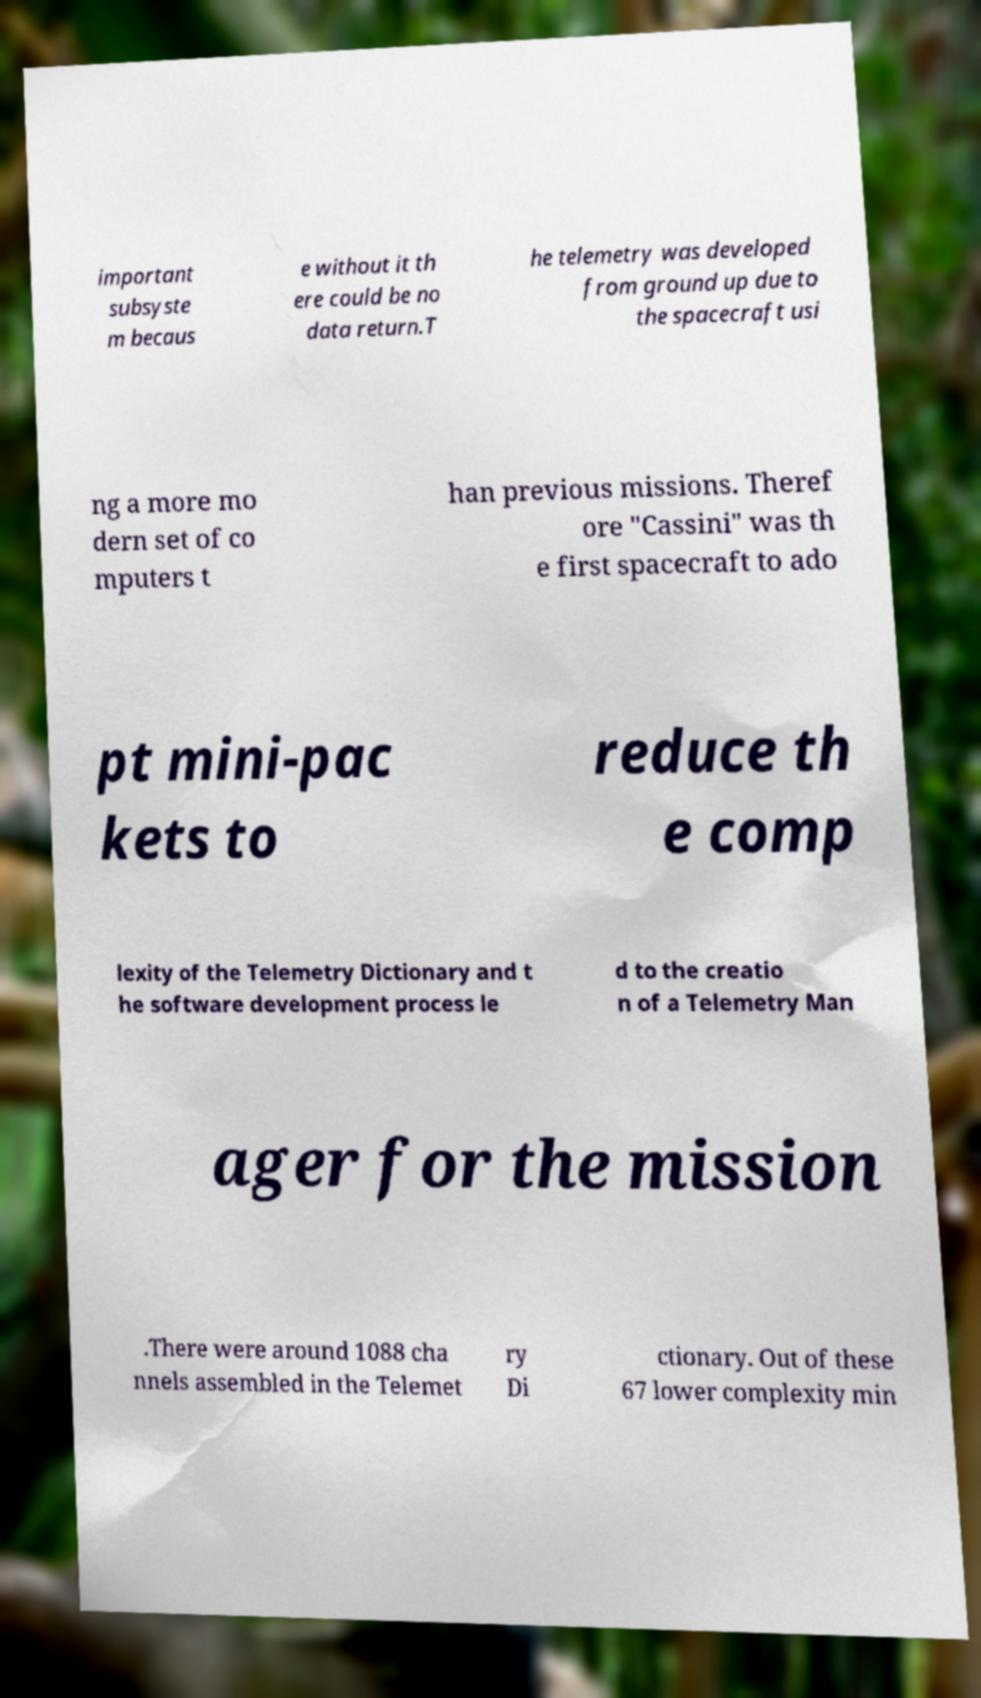Could you extract and type out the text from this image? important subsyste m becaus e without it th ere could be no data return.T he telemetry was developed from ground up due to the spacecraft usi ng a more mo dern set of co mputers t han previous missions. Theref ore "Cassini" was th e first spacecraft to ado pt mini-pac kets to reduce th e comp lexity of the Telemetry Dictionary and t he software development process le d to the creatio n of a Telemetry Man ager for the mission .There were around 1088 cha nnels assembled in the Telemet ry Di ctionary. Out of these 67 lower complexity min 